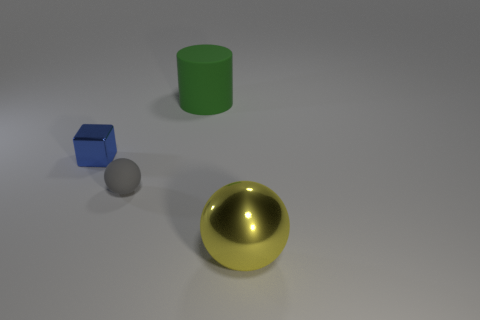There is a green object; how many rubber cylinders are on the left side of it?
Provide a short and direct response. 0. Is there a yellow metallic object of the same size as the green cylinder?
Your answer should be compact. Yes. There is a small matte object that is the same shape as the yellow metallic object; what is its color?
Ensure brevity in your answer.  Gray. Is the size of the metal object right of the tiny metallic thing the same as the metal object that is to the left of the big shiny sphere?
Provide a short and direct response. No. Is there another big thing that has the same shape as the yellow thing?
Offer a very short reply. No. Is the number of blocks behind the green cylinder the same as the number of blue blocks?
Make the answer very short. No. Do the cylinder and the shiny thing that is behind the small gray matte thing have the same size?
Your answer should be compact. No. How many large cylinders are made of the same material as the tiny blue thing?
Make the answer very short. 0. Do the green thing and the yellow shiny thing have the same size?
Your answer should be very brief. Yes. Is there anything else that is the same color as the tiny metallic cube?
Keep it short and to the point. No. 